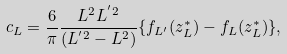<formula> <loc_0><loc_0><loc_500><loc_500>c _ { L } = \frac { 6 } { \pi } \frac { L ^ { 2 } L ^ { ^ { \prime } 2 } } { ( L ^ { ^ { \prime } 2 } - L ^ { 2 } ) } \{ f _ { L ^ { \prime } } ( z _ { L } ^ { * } ) - f _ { L } ( z _ { L } ^ { * } ) \} ,</formula> 